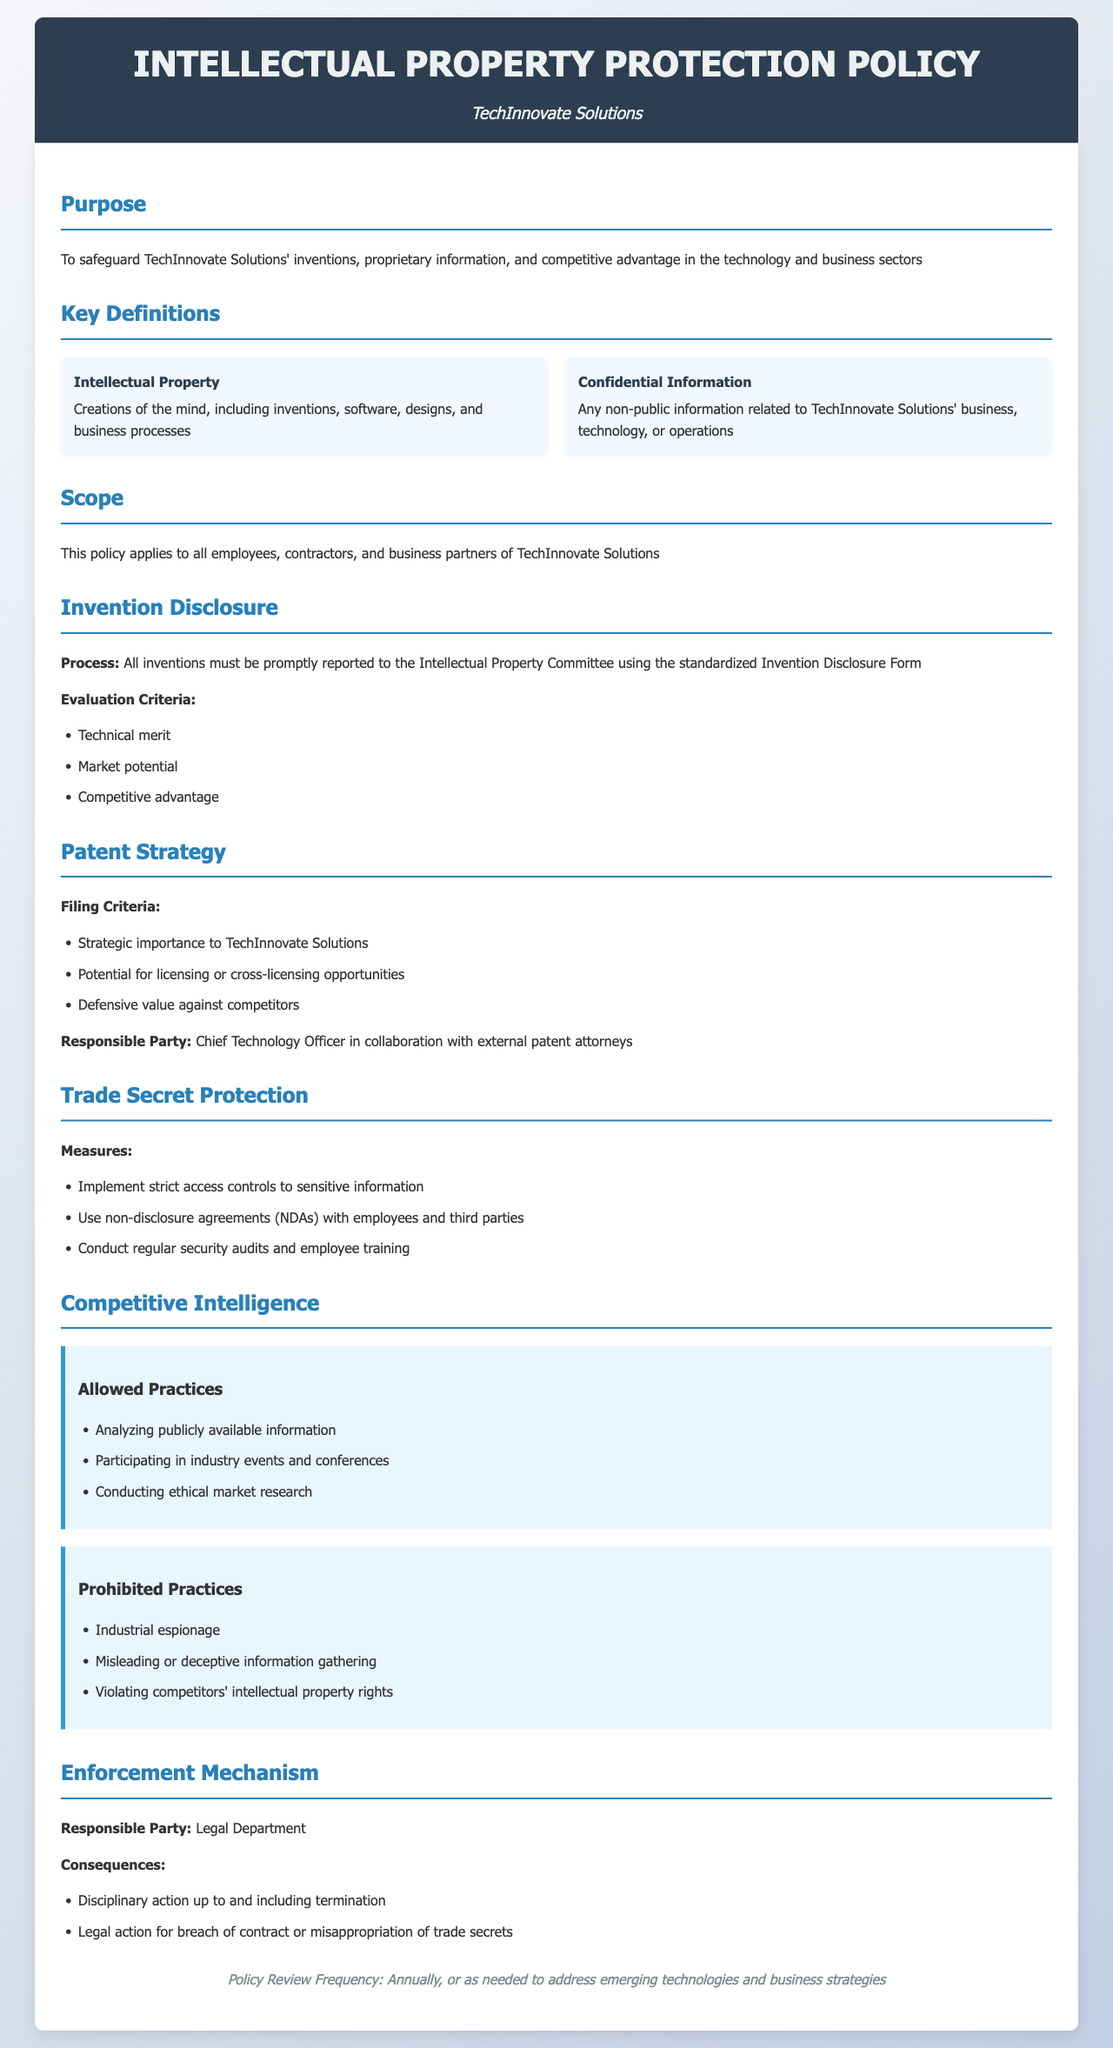What is the purpose of the policy? The purpose is to safeguard TechInnovate Solutions' inventions, proprietary information, and competitive advantage in the technology and business sectors.
Answer: Safeguard inventions and proprietary information Who is responsible for the patent strategy? The responsible party for the patent strategy is mentioned in the document.
Answer: Chief Technology Officer What must all inventions be reported using? The document specifies the method of reporting inventions.
Answer: Invention Disclosure Form What are the allowed practices in competitive intelligence? The document outlines what practices are permitted in competitive intelligence.
Answer: Analyzing publicly available information What are the consequences of breaching the policy? The document states the potential outcomes for violations of the policy.
Answer: Disciplinary action up to and including termination What type of information does the policy cover? The policy includes a specific category of information addressed within the document.
Answer: Confidential Information What is the review frequency of the policy? The policy mentions how often it should be reviewed.
Answer: Annually What measures are specified for trade secret protection? The document lists the steps to ensure trade secret protection.
Answer: Implement strict access controls to sensitive information 